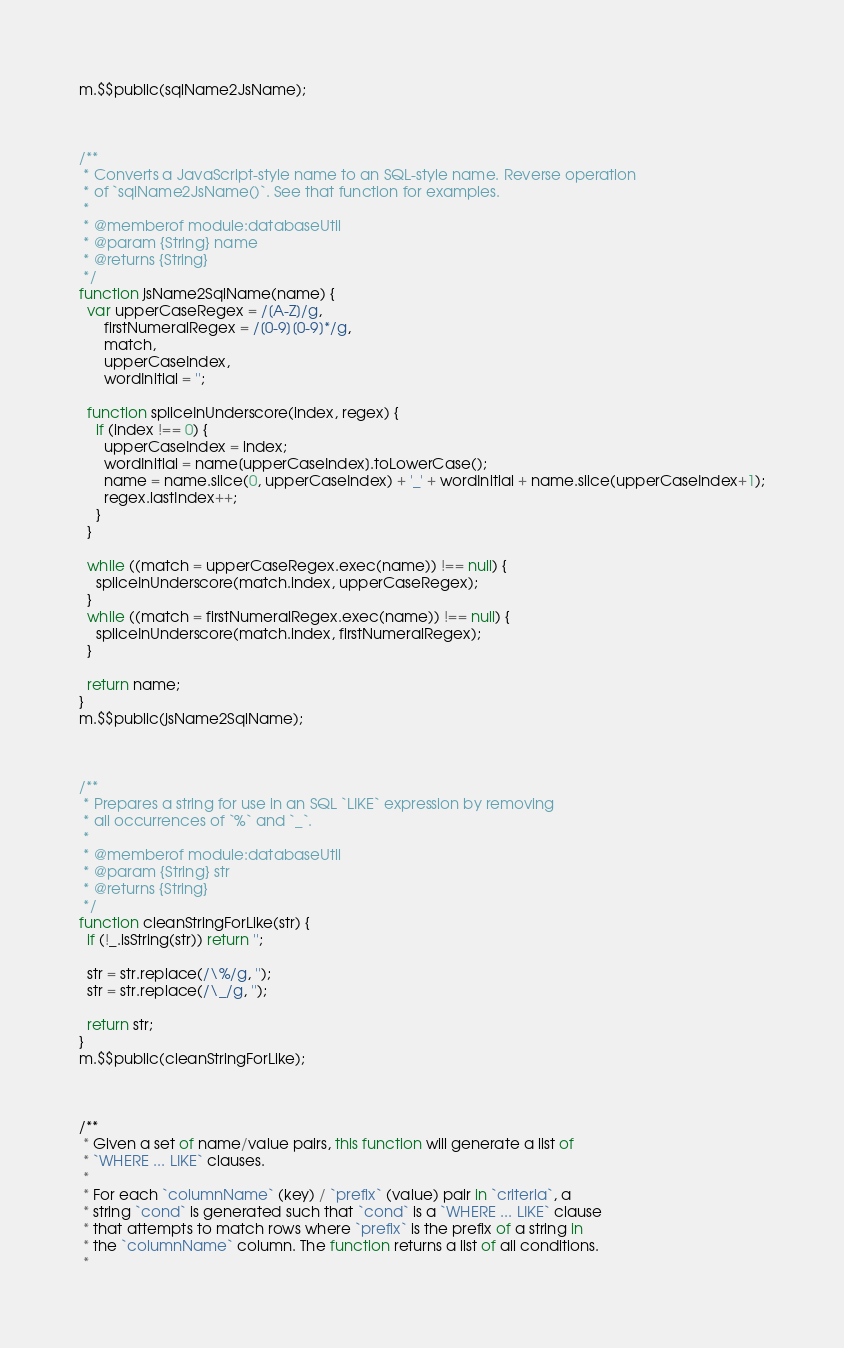<code> <loc_0><loc_0><loc_500><loc_500><_JavaScript_>m.$$public(sqlName2JsName);



/**
 * Converts a JavaScript-style name to an SQL-style name. Reverse operation
 * of `sqlName2JsName()`. See that function for examples.
 *
 * @memberof module:databaseUtil
 * @param {String} name
 * @returns {String}
 */
function jsName2SqlName(name) {
  var upperCaseRegex = /[A-Z]/g,
      firstNumeralRegex = /[0-9][0-9]*/g,
      match,
      upperCaseIndex,
      wordInitial = '';
  
  function spliceInUnderscore(index, regex) {
    if (index !== 0) {
      upperCaseIndex = index;
      wordInitial = name[upperCaseIndex].toLowerCase();
      name = name.slice(0, upperCaseIndex) + '_' + wordInitial + name.slice(upperCaseIndex+1);
      regex.lastIndex++;
    }
  }
      
  while ((match = upperCaseRegex.exec(name)) !== null) {
    spliceInUnderscore(match.index, upperCaseRegex);
  }
  while ((match = firstNumeralRegex.exec(name)) !== null) {
    spliceInUnderscore(match.index, firstNumeralRegex);
  }
  
  return name;
}
m.$$public(jsName2SqlName);



/**
 * Prepares a string for use in an SQL `LIKE` expression by removing
 * all occurrences of `%` and `_`.
 *
 * @memberof module:databaseUtil
 * @param {String} str
 * @returns {String}
 */
function cleanStringForLike(str) {
  if (!_.isString(str)) return '';
  
  str = str.replace(/\%/g, '');
  str = str.replace(/\_/g, '');
  
  return str;
}
m.$$public(cleanStringForLike);



/**
 * Given a set of name/value pairs, this function will generate a list of
 * `WHERE ... LIKE` clauses.
 *
 * For each `columnName` (key) / `prefix` (value) pair in `criteria`, a
 * string `cond` is generated such that `cond` is a `WHERE ... LIKE` clause
 * that attempts to match rows where `prefix` is the prefix of a string in
 * the `columnName` column. The function returns a list of all conditions.
 *</code> 